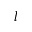<formula> <loc_0><loc_0><loc_500><loc_500>l</formula> 